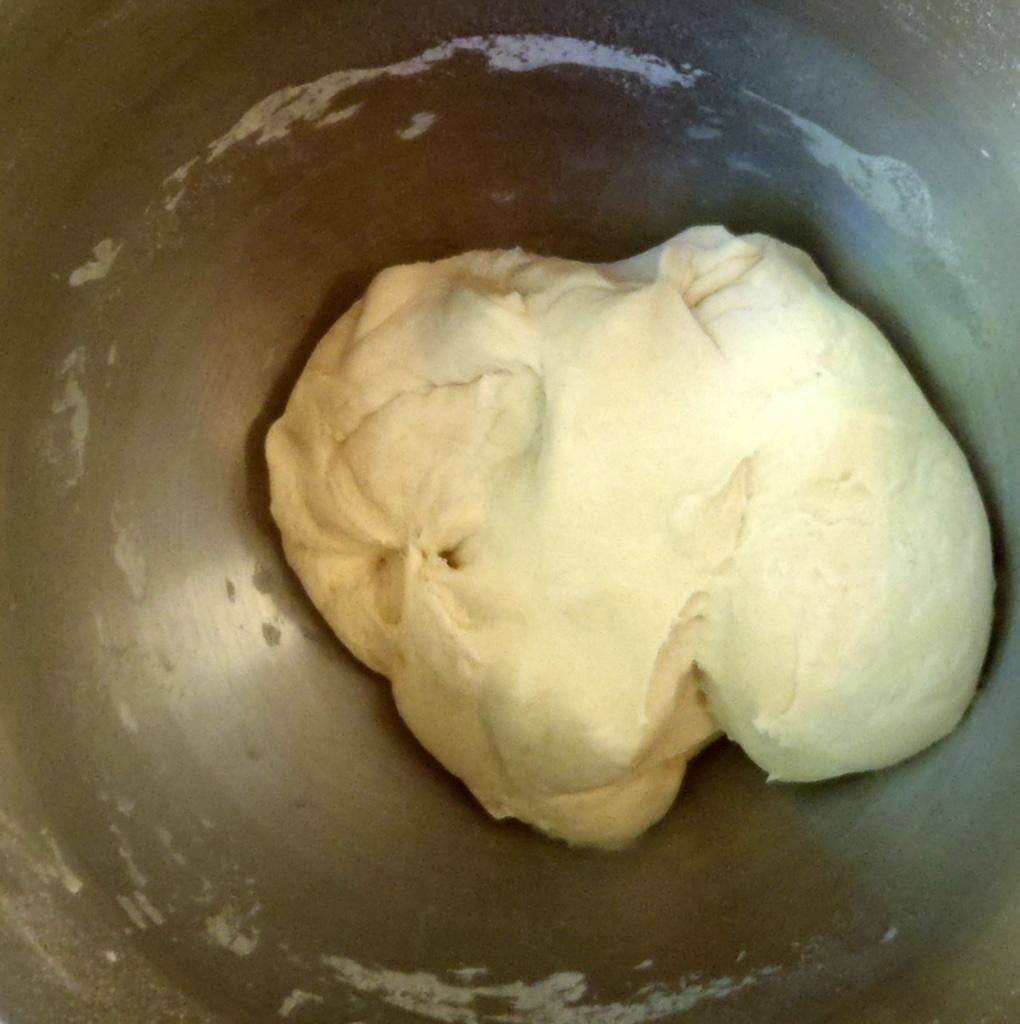Can you describe this image briefly? In this picture we can see flour dough in a container. 